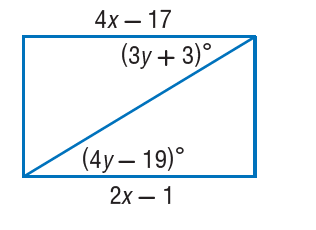Question: Find y so that the quadrilateral is a parallelogram.
Choices:
A. 6
B. 20
C. 22
D. 42
Answer with the letter. Answer: C Question: Find x so that the quadrilateral is a parallelogram.
Choices:
A. 5
B. 8
C. 9
D. 17
Answer with the letter. Answer: B 